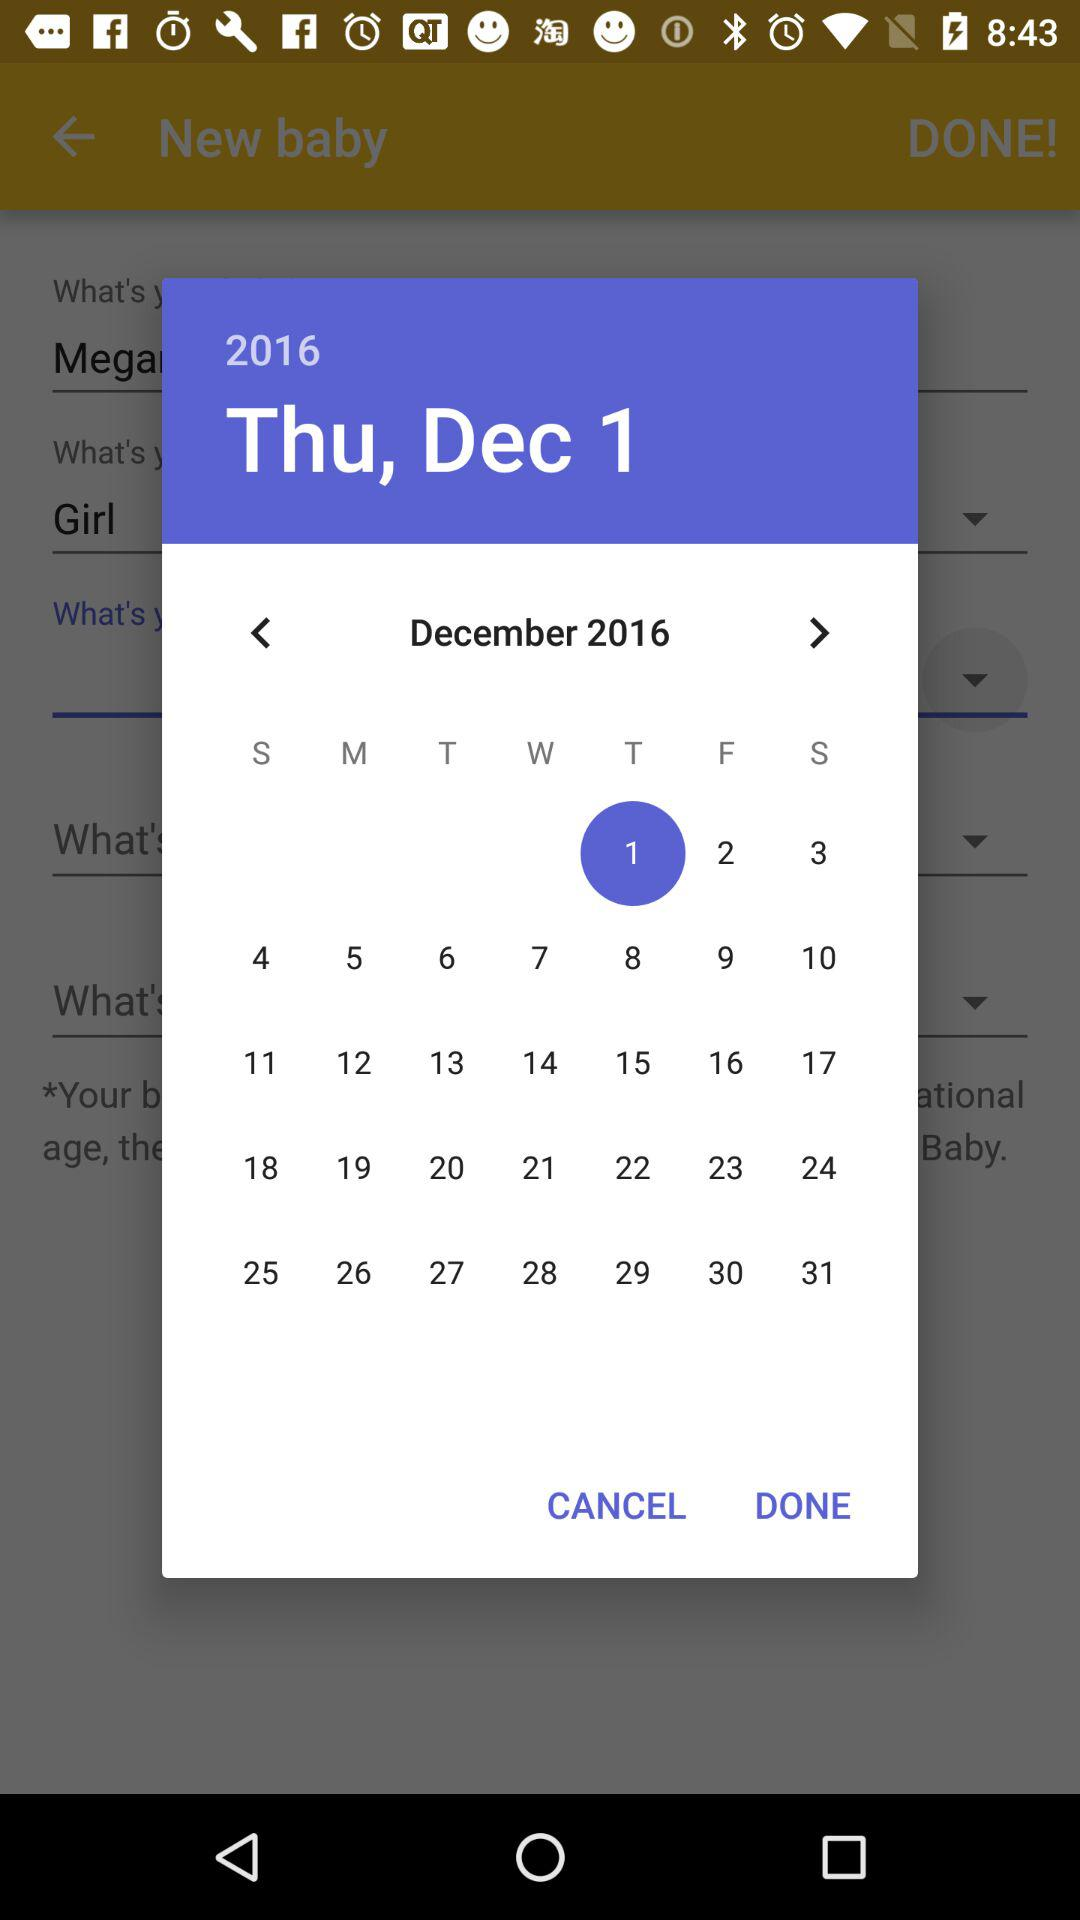What's the selected date? The selected date is Thursday, December 1, 2016. 